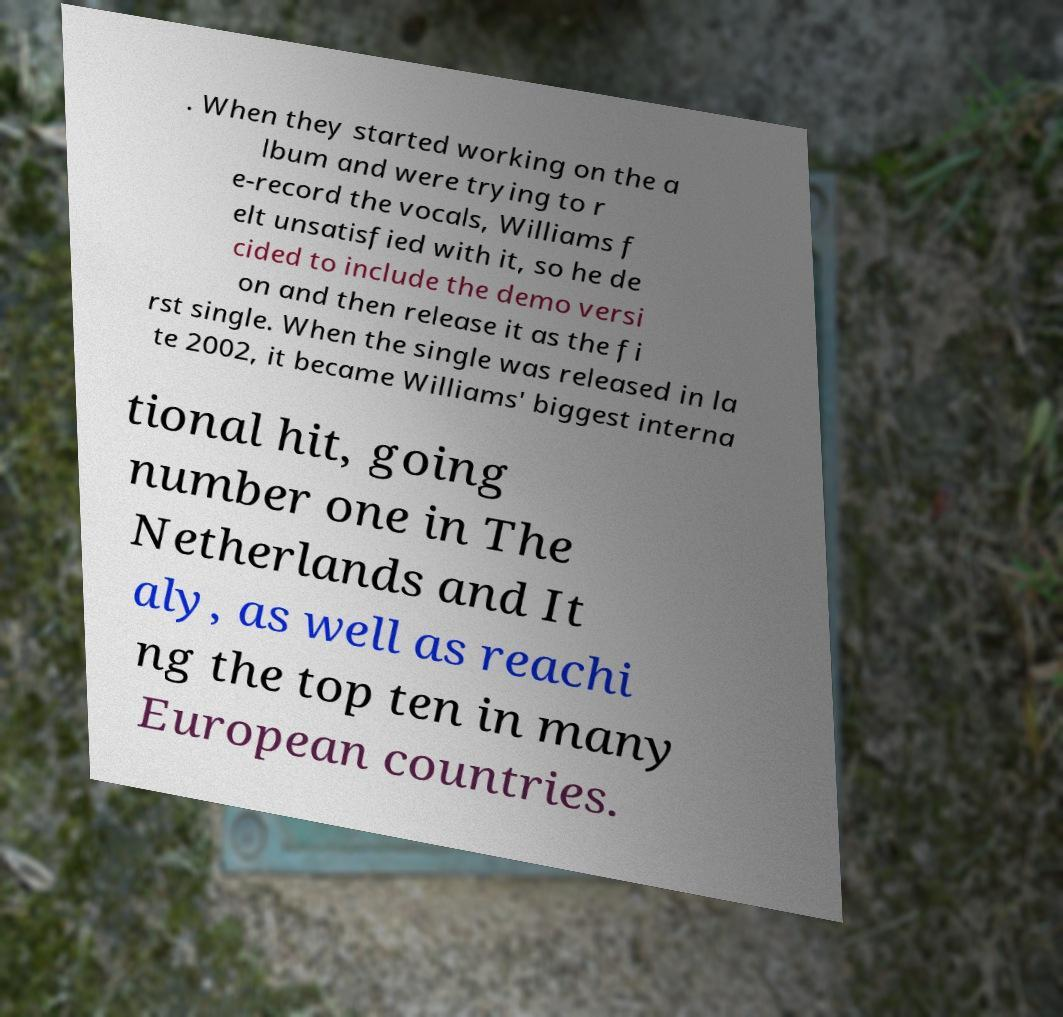There's text embedded in this image that I need extracted. Can you transcribe it verbatim? . When they started working on the a lbum and were trying to r e-record the vocals, Williams f elt unsatisfied with it, so he de cided to include the demo versi on and then release it as the fi rst single. When the single was released in la te 2002, it became Williams' biggest interna tional hit, going number one in The Netherlands and It aly, as well as reachi ng the top ten in many European countries. 